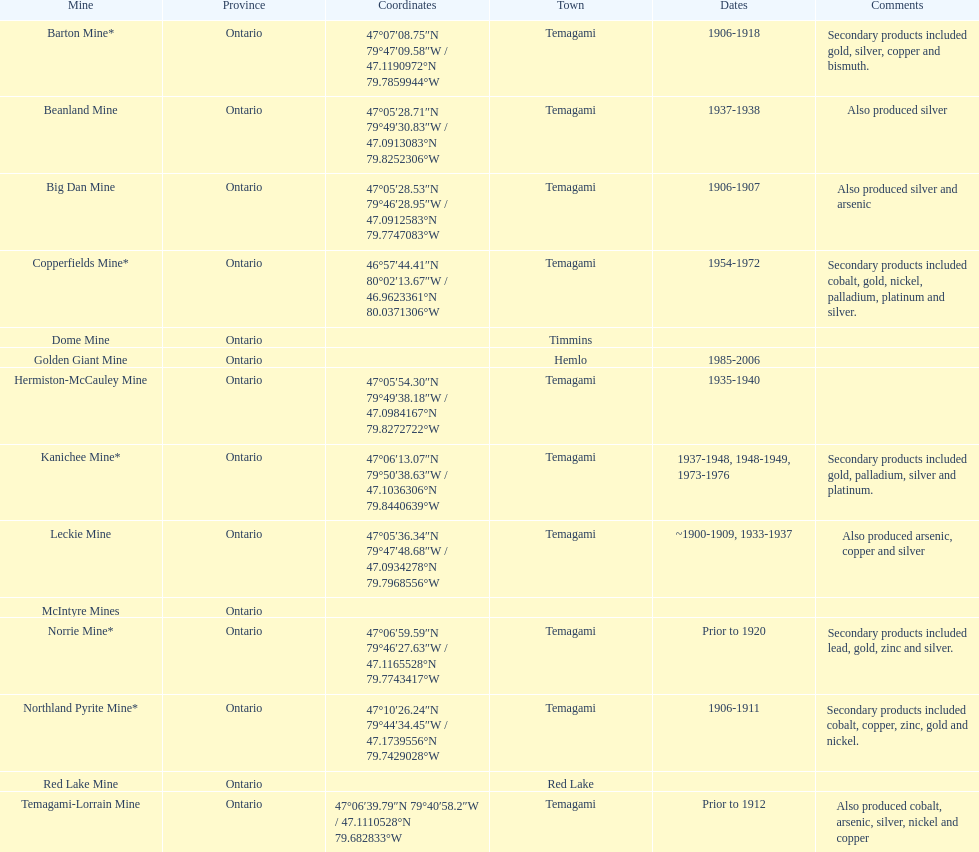Identify a gold mine that was operational for at least a decade. Barton Mine. 